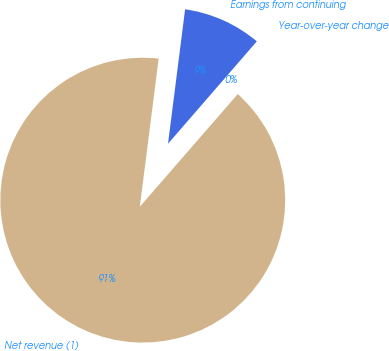Convert chart. <chart><loc_0><loc_0><loc_500><loc_500><pie_chart><fcel>Net revenue (1)<fcel>Year-over-year change<fcel>Earnings from continuing<nl><fcel>90.62%<fcel>0.02%<fcel>9.36%<nl></chart> 